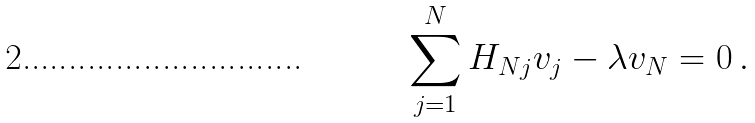Convert formula to latex. <formula><loc_0><loc_0><loc_500><loc_500>\sum _ { j = 1 } ^ { N } H _ { N j } v _ { j } - \lambda v _ { N } = 0 \, .</formula> 